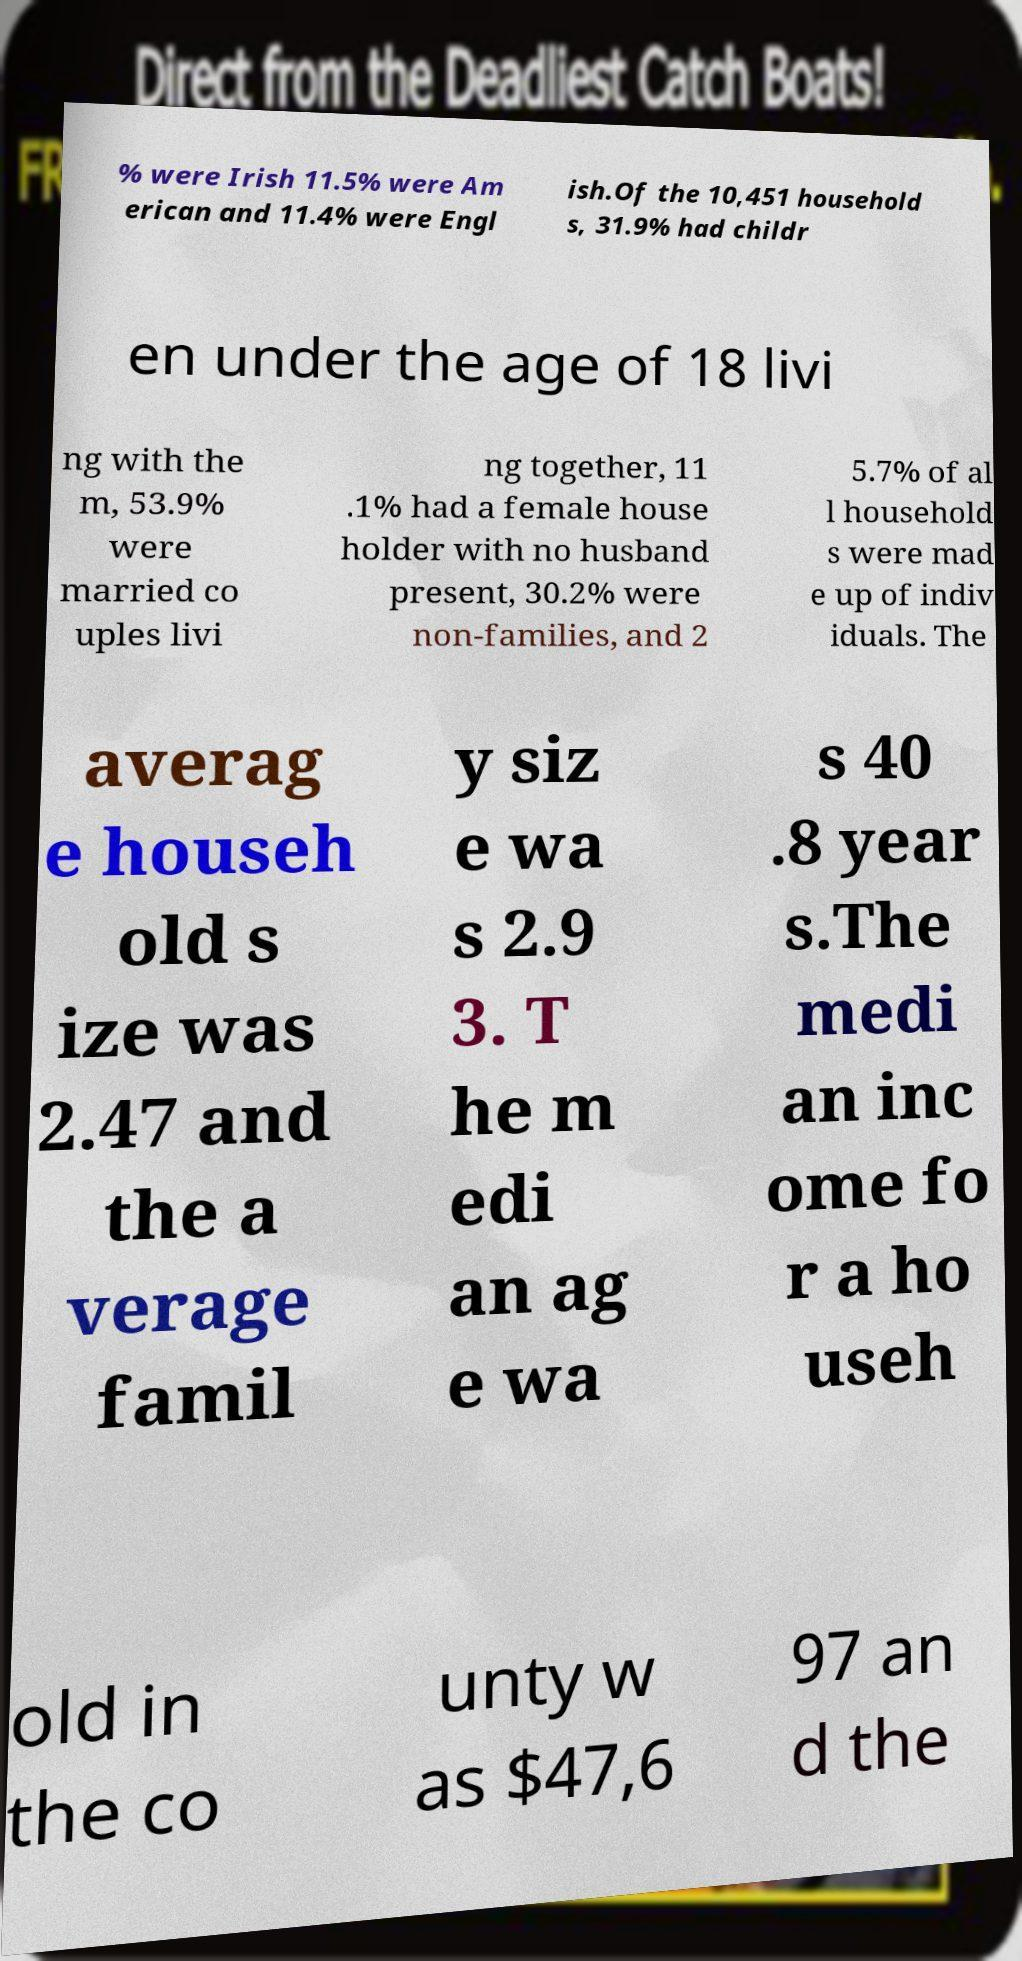For documentation purposes, I need the text within this image transcribed. Could you provide that? % were Irish 11.5% were Am erican and 11.4% were Engl ish.Of the 10,451 household s, 31.9% had childr en under the age of 18 livi ng with the m, 53.9% were married co uples livi ng together, 11 .1% had a female house holder with no husband present, 30.2% were non-families, and 2 5.7% of al l household s were mad e up of indiv iduals. The averag e househ old s ize was 2.47 and the a verage famil y siz e wa s 2.9 3. T he m edi an ag e wa s 40 .8 year s.The medi an inc ome fo r a ho useh old in the co unty w as $47,6 97 an d the 